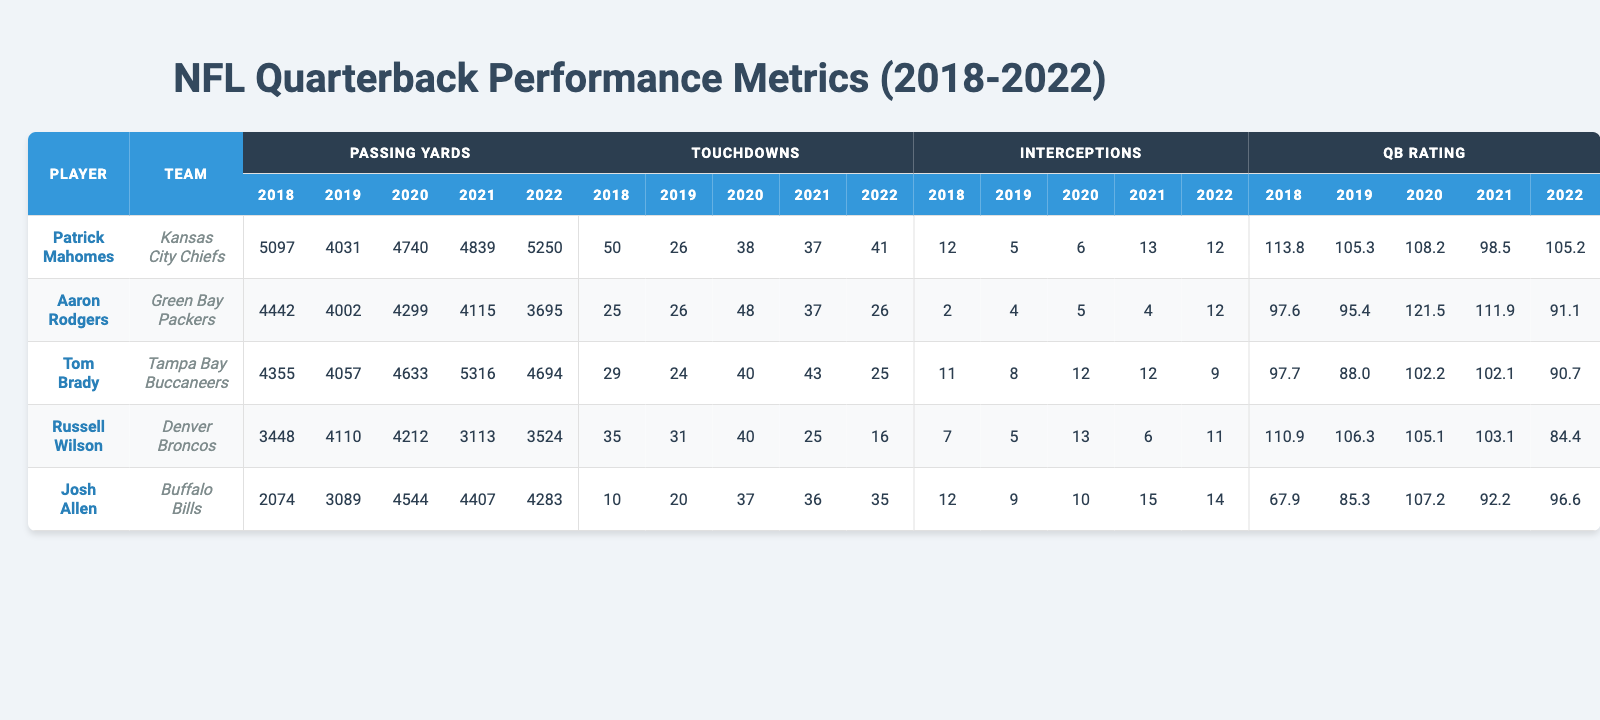What was the highest number of passing yards by Patrick Mahomes in a single season? According to the table, Patrick Mahomes had his highest passing yards in the year 2022 with 5250 yards.
Answer: 5250 Which quarterback had the most touchdowns in 2020? By reviewing the touchdowns column for the year 2020, Aaron Rodgers had the highest number of touchdowns with 48.
Answer: 48 How many touchdowns did Tom Brady throw in 2022? Looking at the touchdowns column for the year 2022, Tom Brady threw a total of 25 touchdowns.
Answer: 25 What is the average number of interceptions for Josh Allen over the five years? Adding Josh Allen’s interceptions: (12 + 9 + 10 + 15 + 14) = 60, and dividing by 5 gives an average of 60/5 = 12.
Answer: 12 Did Russell Wilson ever exceed 40 touchdowns in a single season? Checking the touchdowns column for Russell Wilson, the highest he achieved was 40 in the year 2020, but he did not exceed that number.
Answer: No Who had the best quarterback rating in 2020? By comparing the QB ratings for 2020, the values are: Mahomes (108.2), Rodgers (121.5), Brady (102.2), Wilson (105.1), and Allen (107.2). Aaron Rodgers had the highest rating at 121.5.
Answer: 121.5 In which year did Aaron Rodgers have the lowest quarterback rating? Looking through the QB ratings, Aaron Rodgers had his lowest rating in 2022 at 91.1.
Answer: 2022 What was the total number of touchdowns for Patrick Mahomes from 2018 to 2022? Summing Patrick Mahomes' touchdowns across these years: (50 + 26 + 38 + 37 + 41) = 192.
Answer: 192 Between 2018 and 2021, how many more passing yards did Tom Brady have compared to Russell Wilson? First, sum Brady's passing yards: (4355 + 4057 + 4633 + 5316) = 18361 and Wilson's: (3448 + 4110 + 4212 + 3113) = 14883; the difference is 18361 - 14883 = 3478.
Answer: 3478 Which quarterback had the highest increase in passing yards between 2021 and 2022? Evaluating the passing yards between 2021 (for each QB) and 2022: Mahomes (+411), Brady (-622), Wilson (+411), Allen (-124), and Rodgers (-420). Both Mahomes and Wilson increased by 411 yards, which is the highest increase.
Answer: Mahomes and Wilson 